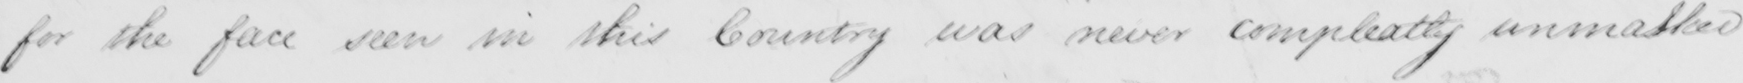Can you read and transcribe this handwriting? for the face seen in this Country was never completely unmatted 